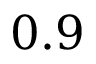Convert formula to latex. <formula><loc_0><loc_0><loc_500><loc_500>0 . 9</formula> 